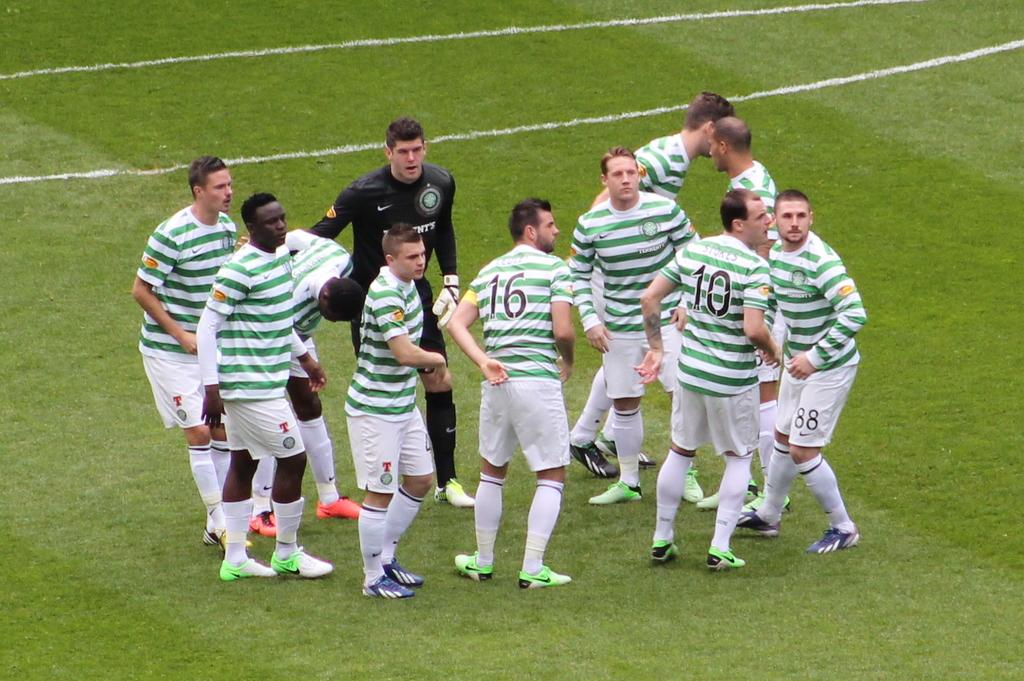<image>
Give a short and clear explanation of the subsequent image. A sports team wears white and green striped uniforms and number 16 it looking to the right. 